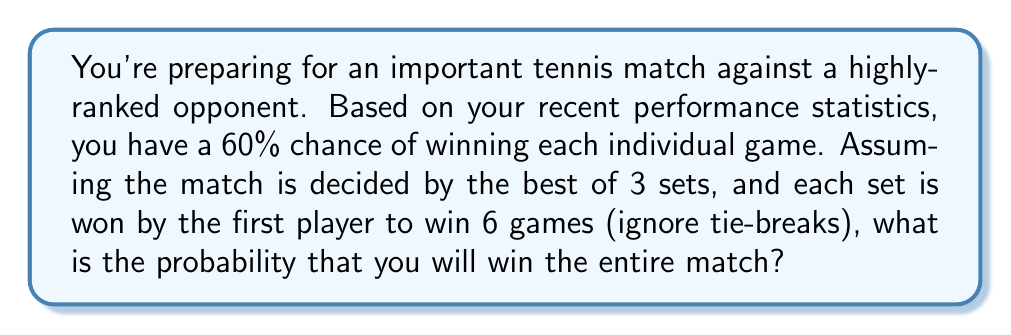Help me with this question. Let's approach this step-by-step:

1) First, we need to calculate the probability of winning a set. To win a set, you need to win 6 games before your opponent does.

2) The probability of winning exactly 6 games in a row is:
   $$(0.6)^6 = 0.047$$

3) However, you can also win a set by winning 6 games and your opponent winning 0 to 5 games. This follows a negative binomial distribution.

4) The probability of winning a set is:

   $$P(\text{win set}) = \sum_{k=0}^5 \binom{6+k-1}{k}(0.6)^6(0.4)^k$$

5) Calculating this:
   $$P(\text{win set}) = 0.710$$

6) Now, to win the match, you need to win 2 sets out of 3. This follows a binomial distribution.

7) The probability of winning the match is:

   $$P(\text{win match}) = \binom{3}{2}(0.710)^2(1-0.710) + \binom{3}{3}(0.710)^3$$

8) Calculating this:
   $$P(\text{win match}) = 3(0.710)^2(0.290) + (0.710)^3 = 0.784$$

Therefore, the probability of winning the entire match is approximately 0.784 or 78.4%.
Answer: 0.784 